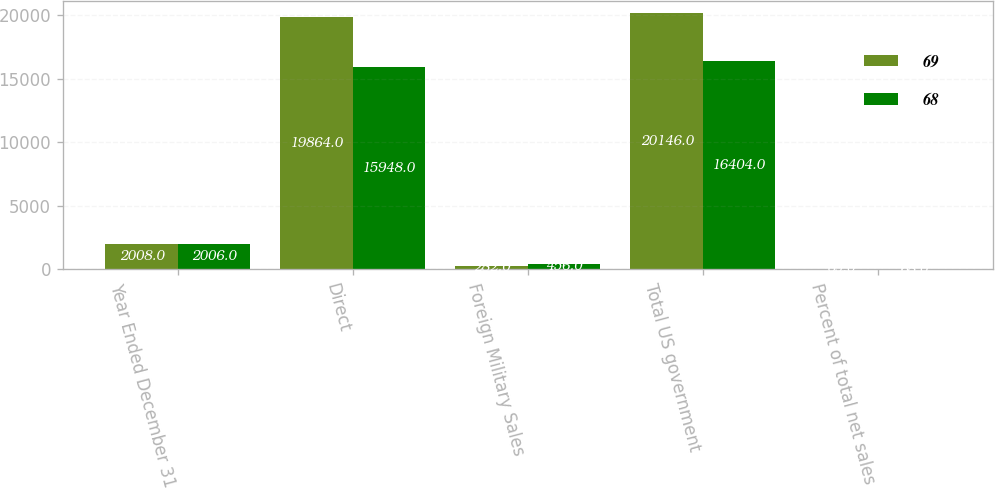Convert chart to OTSL. <chart><loc_0><loc_0><loc_500><loc_500><stacked_bar_chart><ecel><fcel>Year Ended December 31<fcel>Direct<fcel>Foreign Military Sales<fcel>Total US government<fcel>Percent of total net sales<nl><fcel>69<fcel>2008<fcel>19864<fcel>282<fcel>20146<fcel>69<nl><fcel>68<fcel>2006<fcel>15948<fcel>456<fcel>16404<fcel>68<nl></chart> 